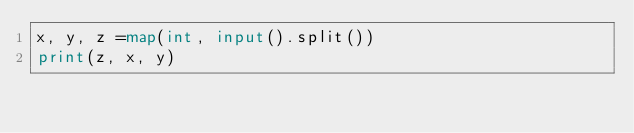Convert code to text. <code><loc_0><loc_0><loc_500><loc_500><_Python_>x, y, z =map(int, input().split())
print(z, x, y)</code> 